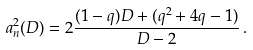Convert formula to latex. <formula><loc_0><loc_0><loc_500><loc_500>a _ { n } ^ { 2 } ( D ) = 2 \frac { ( 1 - q ) D + ( q ^ { 2 } + 4 q - 1 ) } { D - 2 } \, .</formula> 